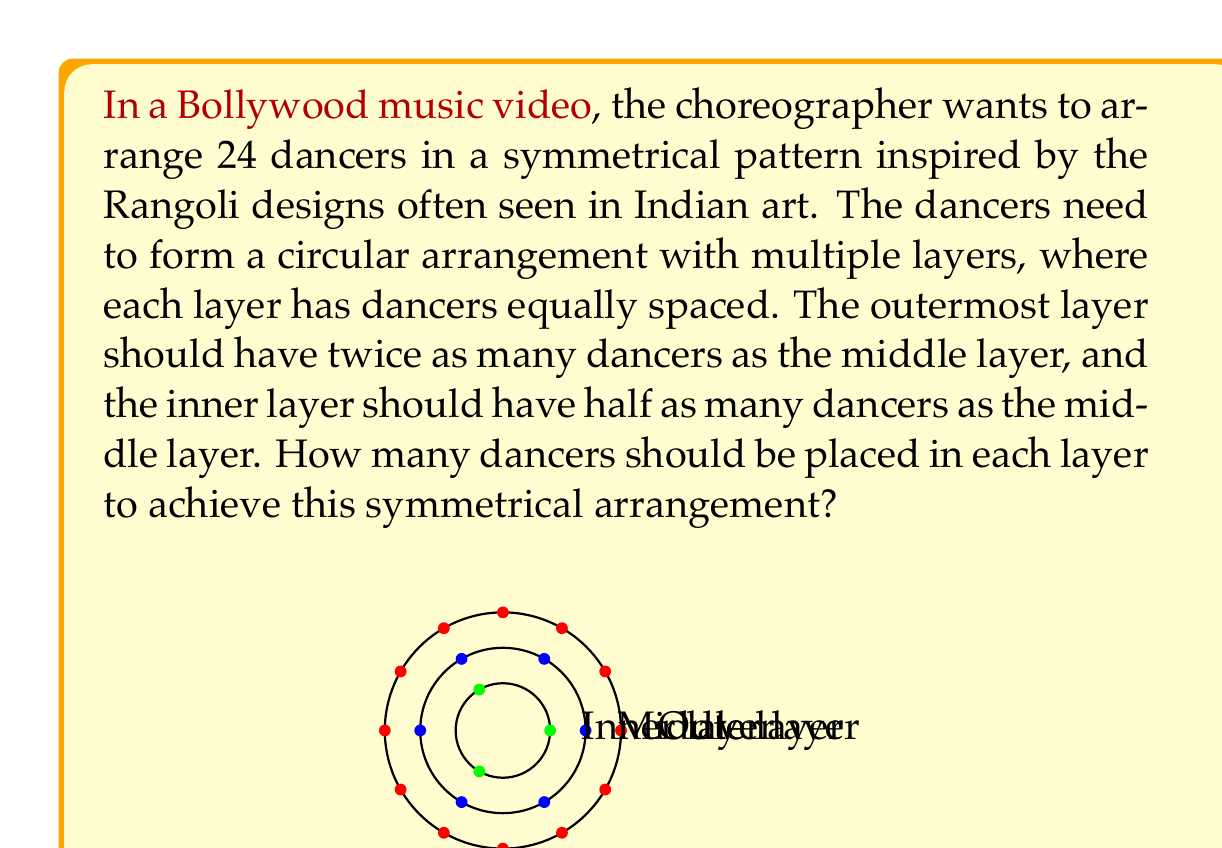What is the answer to this math problem? Let's approach this step-by-step:

1) Let $x$ be the number of dancers in the middle layer.

2) Given the conditions:
   - Outer layer: $2x$ dancers
   - Middle layer: $x$ dancers
   - Inner layer: $\frac{x}{2}$ dancers

3) The total number of dancers is 24, so we can set up an equation:

   $$2x + x + \frac{x}{2} = 24$$

4) Simplify the left side of the equation:

   $$\frac{4x}{2} + \frac{2x}{2} + \frac{x}{2} = 24$$
   $$\frac{7x}{2} = 24$$

5) Multiply both sides by 2:

   $$7x = 48$$

6) Solve for $x$:

   $$x = \frac{48}{7} = 6\frac{6}{7}$$

7) Since we can't have a fractional number of dancers, we round down to 6.

8) Therefore:
   - Middle layer: 6 dancers
   - Outer layer: $2 \times 6 = 12$ dancers
   - Inner layer: $\frac{6}{2} = 3$ dancers

9) Verify: $12 + 6 + 3 = 21$, which is the closest possible arrangement to 24 dancers while maintaining the required ratios.
Answer: Outer layer: 12, Middle layer: 6, Inner layer: 3 